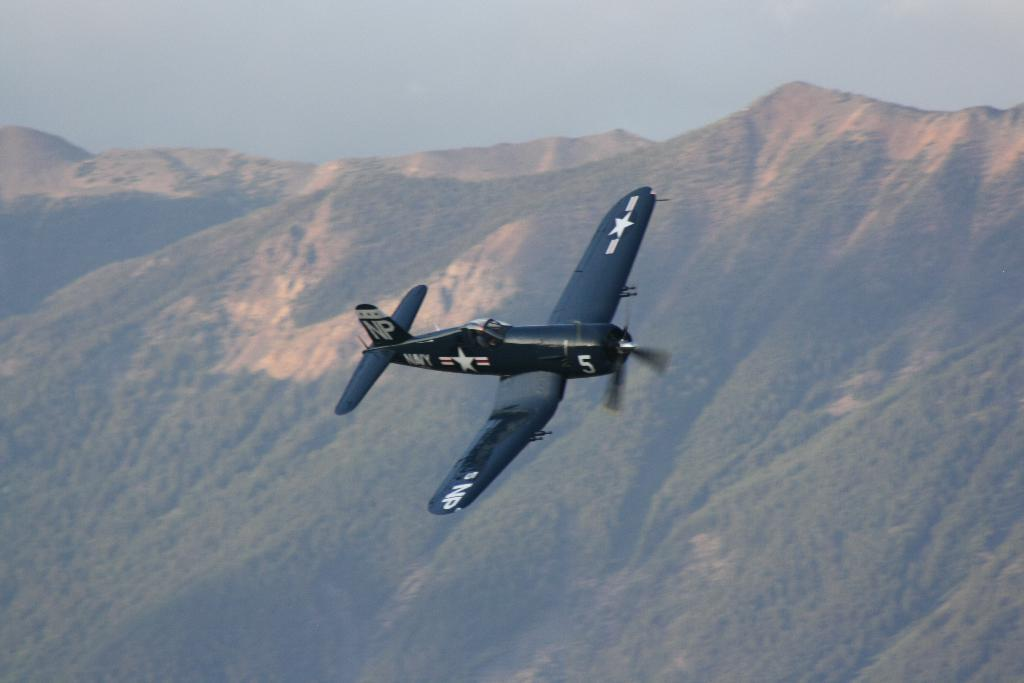What is the main subject of the image? The main subject of the image is an aircraft. Can you describe the position of the aircraft in the image? The aircraft is in the air in the image. What can be seen in the background of the image? Mountains and the sky are visible in the background of the image. What type of toothpaste is being used to clean the aircraft in the image? There is no toothpaste or cleaning activity depicted in the image; it simply shows an aircraft in the air. Can you tell me the punchline of the joke being told by the aircraft in the image? There is no joke being told by the aircraft in the image; it is a still image of an aircraft in the air. 